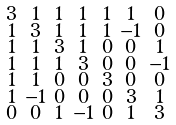<formula> <loc_0><loc_0><loc_500><loc_500>\begin{smallmatrix} 3 & 1 & 1 & 1 & 1 & 1 & 0 \\ 1 & 3 & 1 & 1 & 1 & - 1 & 0 \\ 1 & 1 & 3 & 1 & 0 & 0 & 1 \\ 1 & 1 & 1 & 3 & 0 & 0 & - 1 \\ 1 & 1 & 0 & 0 & 3 & 0 & 0 \\ 1 & - 1 & 0 & 0 & 0 & 3 & 1 \\ 0 & 0 & 1 & - 1 & 0 & 1 & 3 \end{smallmatrix}</formula> 